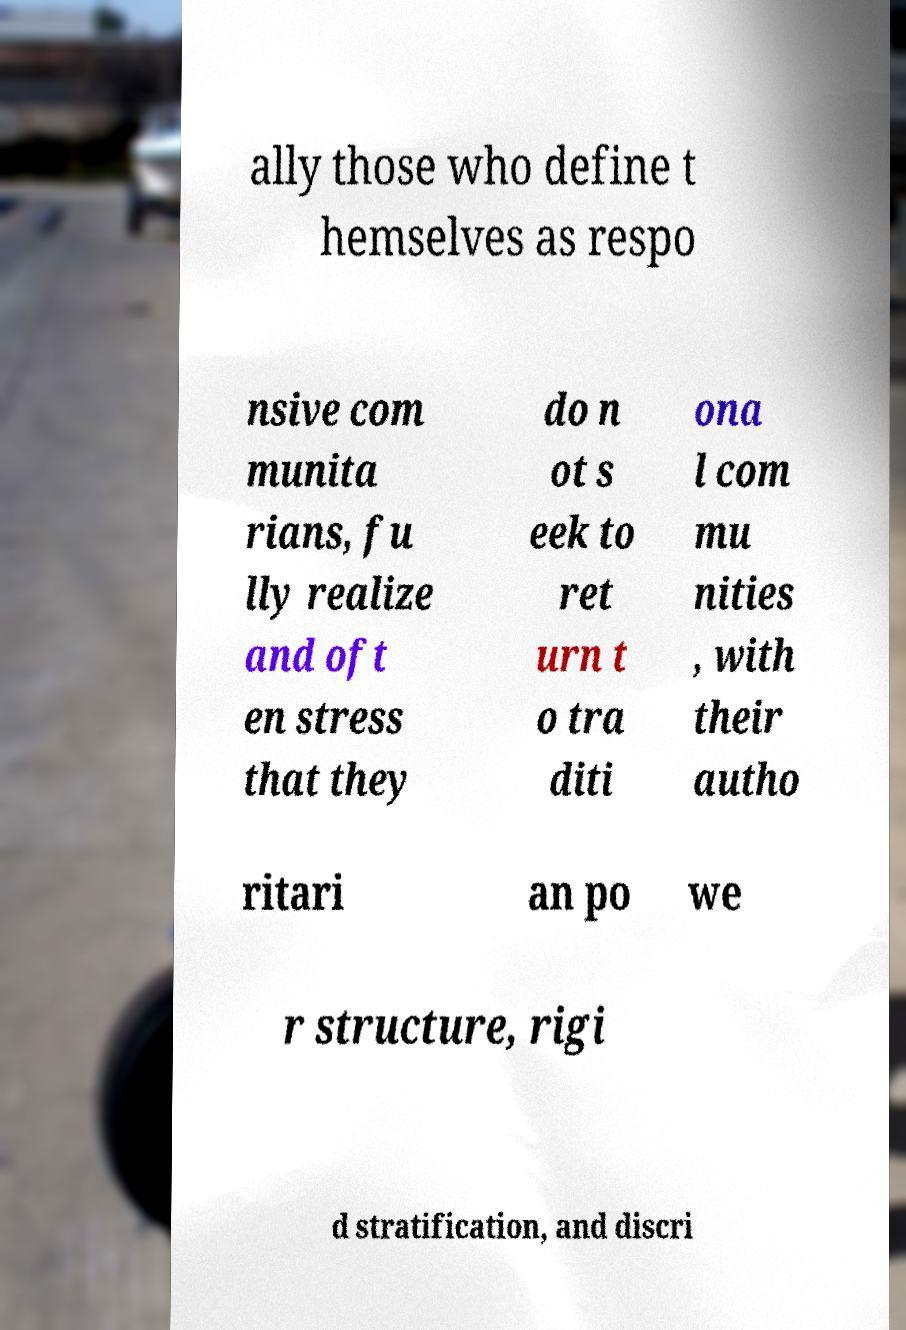Can you read and provide the text displayed in the image?This photo seems to have some interesting text. Can you extract and type it out for me? ally those who define t hemselves as respo nsive com munita rians, fu lly realize and oft en stress that they do n ot s eek to ret urn t o tra diti ona l com mu nities , with their autho ritari an po we r structure, rigi d stratification, and discri 